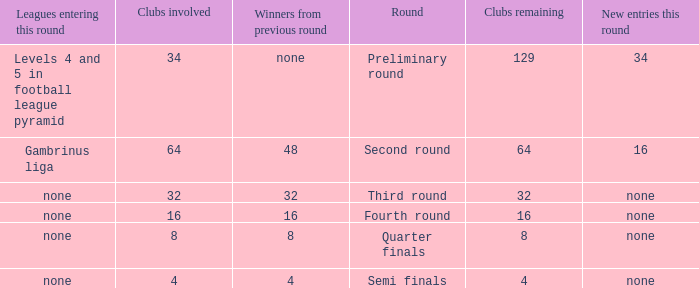Name the least clubs remaining 4.0. 